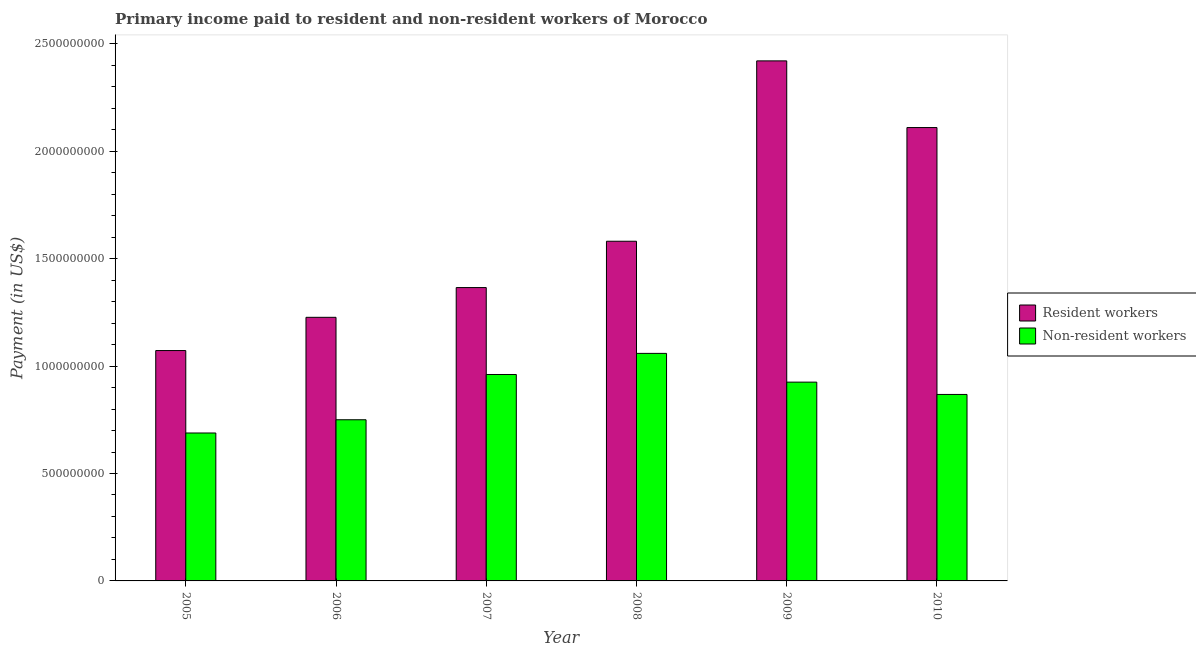How many groups of bars are there?
Your response must be concise. 6. Are the number of bars per tick equal to the number of legend labels?
Give a very brief answer. Yes. How many bars are there on the 3rd tick from the right?
Make the answer very short. 2. In how many cases, is the number of bars for a given year not equal to the number of legend labels?
Your answer should be very brief. 0. What is the payment made to resident workers in 2005?
Offer a very short reply. 1.07e+09. Across all years, what is the maximum payment made to resident workers?
Offer a very short reply. 2.42e+09. Across all years, what is the minimum payment made to resident workers?
Your response must be concise. 1.07e+09. In which year was the payment made to non-resident workers maximum?
Make the answer very short. 2008. What is the total payment made to resident workers in the graph?
Offer a terse response. 9.78e+09. What is the difference between the payment made to non-resident workers in 2006 and that in 2010?
Offer a very short reply. -1.18e+08. What is the difference between the payment made to resident workers in 2010 and the payment made to non-resident workers in 2007?
Ensure brevity in your answer.  7.45e+08. What is the average payment made to non-resident workers per year?
Keep it short and to the point. 8.75e+08. In the year 2006, what is the difference between the payment made to resident workers and payment made to non-resident workers?
Keep it short and to the point. 0. In how many years, is the payment made to resident workers greater than 2000000000 US$?
Give a very brief answer. 2. What is the ratio of the payment made to non-resident workers in 2006 to that in 2007?
Make the answer very short. 0.78. Is the difference between the payment made to non-resident workers in 2005 and 2006 greater than the difference between the payment made to resident workers in 2005 and 2006?
Provide a succinct answer. No. What is the difference between the highest and the second highest payment made to non-resident workers?
Make the answer very short. 9.83e+07. What is the difference between the highest and the lowest payment made to non-resident workers?
Your answer should be compact. 3.71e+08. In how many years, is the payment made to resident workers greater than the average payment made to resident workers taken over all years?
Your answer should be very brief. 2. What does the 1st bar from the left in 2009 represents?
Your answer should be very brief. Resident workers. What does the 2nd bar from the right in 2008 represents?
Offer a terse response. Resident workers. Are all the bars in the graph horizontal?
Your answer should be compact. No. How many years are there in the graph?
Offer a terse response. 6. What is the difference between two consecutive major ticks on the Y-axis?
Provide a short and direct response. 5.00e+08. Does the graph contain any zero values?
Offer a very short reply. No. Does the graph contain grids?
Provide a short and direct response. No. Where does the legend appear in the graph?
Provide a short and direct response. Center right. What is the title of the graph?
Offer a very short reply. Primary income paid to resident and non-resident workers of Morocco. What is the label or title of the Y-axis?
Provide a short and direct response. Payment (in US$). What is the Payment (in US$) of Resident workers in 2005?
Offer a terse response. 1.07e+09. What is the Payment (in US$) of Non-resident workers in 2005?
Your answer should be very brief. 6.89e+08. What is the Payment (in US$) in Resident workers in 2006?
Give a very brief answer. 1.23e+09. What is the Payment (in US$) of Non-resident workers in 2006?
Offer a terse response. 7.50e+08. What is the Payment (in US$) in Resident workers in 2007?
Keep it short and to the point. 1.37e+09. What is the Payment (in US$) of Non-resident workers in 2007?
Offer a terse response. 9.61e+08. What is the Payment (in US$) of Resident workers in 2008?
Offer a terse response. 1.58e+09. What is the Payment (in US$) in Non-resident workers in 2008?
Ensure brevity in your answer.  1.06e+09. What is the Payment (in US$) in Resident workers in 2009?
Offer a terse response. 2.42e+09. What is the Payment (in US$) of Non-resident workers in 2009?
Make the answer very short. 9.25e+08. What is the Payment (in US$) of Resident workers in 2010?
Give a very brief answer. 2.11e+09. What is the Payment (in US$) of Non-resident workers in 2010?
Ensure brevity in your answer.  8.68e+08. Across all years, what is the maximum Payment (in US$) of Resident workers?
Provide a succinct answer. 2.42e+09. Across all years, what is the maximum Payment (in US$) in Non-resident workers?
Your answer should be compact. 1.06e+09. Across all years, what is the minimum Payment (in US$) in Resident workers?
Give a very brief answer. 1.07e+09. Across all years, what is the minimum Payment (in US$) of Non-resident workers?
Your answer should be compact. 6.89e+08. What is the total Payment (in US$) in Resident workers in the graph?
Ensure brevity in your answer.  9.78e+09. What is the total Payment (in US$) of Non-resident workers in the graph?
Your response must be concise. 5.25e+09. What is the difference between the Payment (in US$) in Resident workers in 2005 and that in 2006?
Your answer should be very brief. -1.55e+08. What is the difference between the Payment (in US$) of Non-resident workers in 2005 and that in 2006?
Provide a succinct answer. -6.16e+07. What is the difference between the Payment (in US$) in Resident workers in 2005 and that in 2007?
Your response must be concise. -2.93e+08. What is the difference between the Payment (in US$) of Non-resident workers in 2005 and that in 2007?
Offer a very short reply. -2.72e+08. What is the difference between the Payment (in US$) in Resident workers in 2005 and that in 2008?
Offer a very short reply. -5.09e+08. What is the difference between the Payment (in US$) in Non-resident workers in 2005 and that in 2008?
Your response must be concise. -3.71e+08. What is the difference between the Payment (in US$) of Resident workers in 2005 and that in 2009?
Your answer should be compact. -1.35e+09. What is the difference between the Payment (in US$) of Non-resident workers in 2005 and that in 2009?
Provide a short and direct response. -2.37e+08. What is the difference between the Payment (in US$) of Resident workers in 2005 and that in 2010?
Your answer should be compact. -1.04e+09. What is the difference between the Payment (in US$) in Non-resident workers in 2005 and that in 2010?
Your response must be concise. -1.79e+08. What is the difference between the Payment (in US$) of Resident workers in 2006 and that in 2007?
Offer a terse response. -1.39e+08. What is the difference between the Payment (in US$) in Non-resident workers in 2006 and that in 2007?
Your answer should be very brief. -2.11e+08. What is the difference between the Payment (in US$) in Resident workers in 2006 and that in 2008?
Keep it short and to the point. -3.54e+08. What is the difference between the Payment (in US$) in Non-resident workers in 2006 and that in 2008?
Make the answer very short. -3.09e+08. What is the difference between the Payment (in US$) in Resident workers in 2006 and that in 2009?
Your answer should be compact. -1.19e+09. What is the difference between the Payment (in US$) in Non-resident workers in 2006 and that in 2009?
Provide a short and direct response. -1.75e+08. What is the difference between the Payment (in US$) of Resident workers in 2006 and that in 2010?
Give a very brief answer. -8.83e+08. What is the difference between the Payment (in US$) of Non-resident workers in 2006 and that in 2010?
Your answer should be compact. -1.18e+08. What is the difference between the Payment (in US$) in Resident workers in 2007 and that in 2008?
Make the answer very short. -2.16e+08. What is the difference between the Payment (in US$) in Non-resident workers in 2007 and that in 2008?
Offer a very short reply. -9.83e+07. What is the difference between the Payment (in US$) in Resident workers in 2007 and that in 2009?
Keep it short and to the point. -1.06e+09. What is the difference between the Payment (in US$) in Non-resident workers in 2007 and that in 2009?
Give a very brief answer. 3.55e+07. What is the difference between the Payment (in US$) in Resident workers in 2007 and that in 2010?
Your response must be concise. -7.45e+08. What is the difference between the Payment (in US$) in Non-resident workers in 2007 and that in 2010?
Your response must be concise. 9.28e+07. What is the difference between the Payment (in US$) in Resident workers in 2008 and that in 2009?
Offer a terse response. -8.40e+08. What is the difference between the Payment (in US$) in Non-resident workers in 2008 and that in 2009?
Keep it short and to the point. 1.34e+08. What is the difference between the Payment (in US$) of Resident workers in 2008 and that in 2010?
Give a very brief answer. -5.29e+08. What is the difference between the Payment (in US$) of Non-resident workers in 2008 and that in 2010?
Make the answer very short. 1.91e+08. What is the difference between the Payment (in US$) of Resident workers in 2009 and that in 2010?
Provide a succinct answer. 3.10e+08. What is the difference between the Payment (in US$) in Non-resident workers in 2009 and that in 2010?
Ensure brevity in your answer.  5.73e+07. What is the difference between the Payment (in US$) of Resident workers in 2005 and the Payment (in US$) of Non-resident workers in 2006?
Your response must be concise. 3.22e+08. What is the difference between the Payment (in US$) of Resident workers in 2005 and the Payment (in US$) of Non-resident workers in 2007?
Keep it short and to the point. 1.11e+08. What is the difference between the Payment (in US$) in Resident workers in 2005 and the Payment (in US$) in Non-resident workers in 2008?
Your answer should be compact. 1.32e+07. What is the difference between the Payment (in US$) in Resident workers in 2005 and the Payment (in US$) in Non-resident workers in 2009?
Give a very brief answer. 1.47e+08. What is the difference between the Payment (in US$) in Resident workers in 2005 and the Payment (in US$) in Non-resident workers in 2010?
Ensure brevity in your answer.  2.04e+08. What is the difference between the Payment (in US$) in Resident workers in 2006 and the Payment (in US$) in Non-resident workers in 2007?
Ensure brevity in your answer.  2.66e+08. What is the difference between the Payment (in US$) in Resident workers in 2006 and the Payment (in US$) in Non-resident workers in 2008?
Provide a succinct answer. 1.68e+08. What is the difference between the Payment (in US$) in Resident workers in 2006 and the Payment (in US$) in Non-resident workers in 2009?
Make the answer very short. 3.02e+08. What is the difference between the Payment (in US$) in Resident workers in 2006 and the Payment (in US$) in Non-resident workers in 2010?
Your answer should be compact. 3.59e+08. What is the difference between the Payment (in US$) in Resident workers in 2007 and the Payment (in US$) in Non-resident workers in 2008?
Offer a terse response. 3.06e+08. What is the difference between the Payment (in US$) of Resident workers in 2007 and the Payment (in US$) of Non-resident workers in 2009?
Ensure brevity in your answer.  4.40e+08. What is the difference between the Payment (in US$) of Resident workers in 2007 and the Payment (in US$) of Non-resident workers in 2010?
Keep it short and to the point. 4.97e+08. What is the difference between the Payment (in US$) of Resident workers in 2008 and the Payment (in US$) of Non-resident workers in 2009?
Make the answer very short. 6.56e+08. What is the difference between the Payment (in US$) in Resident workers in 2008 and the Payment (in US$) in Non-resident workers in 2010?
Offer a terse response. 7.13e+08. What is the difference between the Payment (in US$) of Resident workers in 2009 and the Payment (in US$) of Non-resident workers in 2010?
Provide a short and direct response. 1.55e+09. What is the average Payment (in US$) in Resident workers per year?
Ensure brevity in your answer.  1.63e+09. What is the average Payment (in US$) of Non-resident workers per year?
Make the answer very short. 8.75e+08. In the year 2005, what is the difference between the Payment (in US$) of Resident workers and Payment (in US$) of Non-resident workers?
Your answer should be compact. 3.84e+08. In the year 2006, what is the difference between the Payment (in US$) in Resident workers and Payment (in US$) in Non-resident workers?
Keep it short and to the point. 4.77e+08. In the year 2007, what is the difference between the Payment (in US$) in Resident workers and Payment (in US$) in Non-resident workers?
Provide a short and direct response. 4.05e+08. In the year 2008, what is the difference between the Payment (in US$) of Resident workers and Payment (in US$) of Non-resident workers?
Make the answer very short. 5.22e+08. In the year 2009, what is the difference between the Payment (in US$) in Resident workers and Payment (in US$) in Non-resident workers?
Offer a terse response. 1.50e+09. In the year 2010, what is the difference between the Payment (in US$) in Resident workers and Payment (in US$) in Non-resident workers?
Your answer should be compact. 1.24e+09. What is the ratio of the Payment (in US$) in Resident workers in 2005 to that in 2006?
Your response must be concise. 0.87. What is the ratio of the Payment (in US$) of Non-resident workers in 2005 to that in 2006?
Offer a very short reply. 0.92. What is the ratio of the Payment (in US$) of Resident workers in 2005 to that in 2007?
Your response must be concise. 0.79. What is the ratio of the Payment (in US$) of Non-resident workers in 2005 to that in 2007?
Give a very brief answer. 0.72. What is the ratio of the Payment (in US$) in Resident workers in 2005 to that in 2008?
Offer a terse response. 0.68. What is the ratio of the Payment (in US$) in Non-resident workers in 2005 to that in 2008?
Keep it short and to the point. 0.65. What is the ratio of the Payment (in US$) of Resident workers in 2005 to that in 2009?
Ensure brevity in your answer.  0.44. What is the ratio of the Payment (in US$) of Non-resident workers in 2005 to that in 2009?
Make the answer very short. 0.74. What is the ratio of the Payment (in US$) of Resident workers in 2005 to that in 2010?
Provide a succinct answer. 0.51. What is the ratio of the Payment (in US$) in Non-resident workers in 2005 to that in 2010?
Offer a terse response. 0.79. What is the ratio of the Payment (in US$) of Resident workers in 2006 to that in 2007?
Your answer should be compact. 0.9. What is the ratio of the Payment (in US$) in Non-resident workers in 2006 to that in 2007?
Provide a short and direct response. 0.78. What is the ratio of the Payment (in US$) of Resident workers in 2006 to that in 2008?
Your answer should be compact. 0.78. What is the ratio of the Payment (in US$) of Non-resident workers in 2006 to that in 2008?
Provide a short and direct response. 0.71. What is the ratio of the Payment (in US$) of Resident workers in 2006 to that in 2009?
Give a very brief answer. 0.51. What is the ratio of the Payment (in US$) in Non-resident workers in 2006 to that in 2009?
Ensure brevity in your answer.  0.81. What is the ratio of the Payment (in US$) of Resident workers in 2006 to that in 2010?
Your answer should be very brief. 0.58. What is the ratio of the Payment (in US$) in Non-resident workers in 2006 to that in 2010?
Your response must be concise. 0.86. What is the ratio of the Payment (in US$) in Resident workers in 2007 to that in 2008?
Make the answer very short. 0.86. What is the ratio of the Payment (in US$) in Non-resident workers in 2007 to that in 2008?
Your response must be concise. 0.91. What is the ratio of the Payment (in US$) of Resident workers in 2007 to that in 2009?
Your response must be concise. 0.56. What is the ratio of the Payment (in US$) in Non-resident workers in 2007 to that in 2009?
Ensure brevity in your answer.  1.04. What is the ratio of the Payment (in US$) of Resident workers in 2007 to that in 2010?
Provide a short and direct response. 0.65. What is the ratio of the Payment (in US$) of Non-resident workers in 2007 to that in 2010?
Your response must be concise. 1.11. What is the ratio of the Payment (in US$) of Resident workers in 2008 to that in 2009?
Make the answer very short. 0.65. What is the ratio of the Payment (in US$) of Non-resident workers in 2008 to that in 2009?
Offer a terse response. 1.14. What is the ratio of the Payment (in US$) in Resident workers in 2008 to that in 2010?
Make the answer very short. 0.75. What is the ratio of the Payment (in US$) in Non-resident workers in 2008 to that in 2010?
Your response must be concise. 1.22. What is the ratio of the Payment (in US$) of Resident workers in 2009 to that in 2010?
Offer a very short reply. 1.15. What is the ratio of the Payment (in US$) of Non-resident workers in 2009 to that in 2010?
Your answer should be very brief. 1.07. What is the difference between the highest and the second highest Payment (in US$) in Resident workers?
Offer a terse response. 3.10e+08. What is the difference between the highest and the second highest Payment (in US$) in Non-resident workers?
Your answer should be compact. 9.83e+07. What is the difference between the highest and the lowest Payment (in US$) of Resident workers?
Offer a terse response. 1.35e+09. What is the difference between the highest and the lowest Payment (in US$) of Non-resident workers?
Provide a succinct answer. 3.71e+08. 